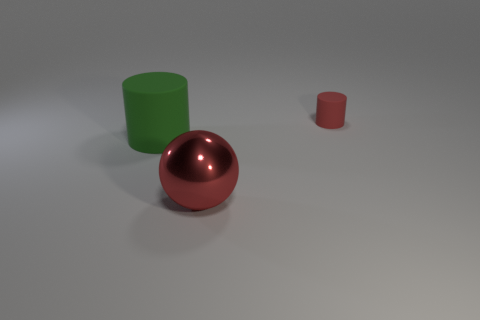Add 2 tiny metallic spheres. How many objects exist? 5 Subtract all red cylinders. How many cylinders are left? 1 Subtract 0 brown blocks. How many objects are left? 3 Subtract all balls. How many objects are left? 2 Subtract all cyan spheres. Subtract all purple cylinders. How many spheres are left? 1 Subtract all blue cylinders. How many brown balls are left? 0 Subtract all tiny red matte objects. Subtract all small rubber things. How many objects are left? 1 Add 3 tiny red rubber objects. How many tiny red rubber objects are left? 4 Add 2 green cylinders. How many green cylinders exist? 3 